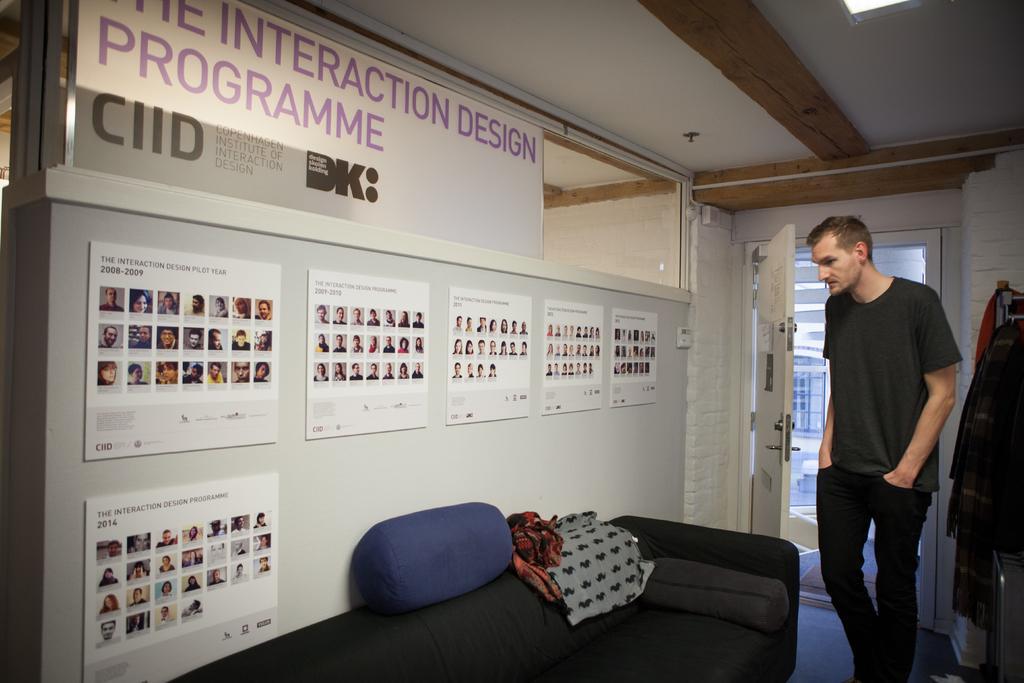Can you describe this image briefly? In this picture we can see a man standing, sofa with pillows on it, posters on the wall, door, clothes and in the background we can see a window. 